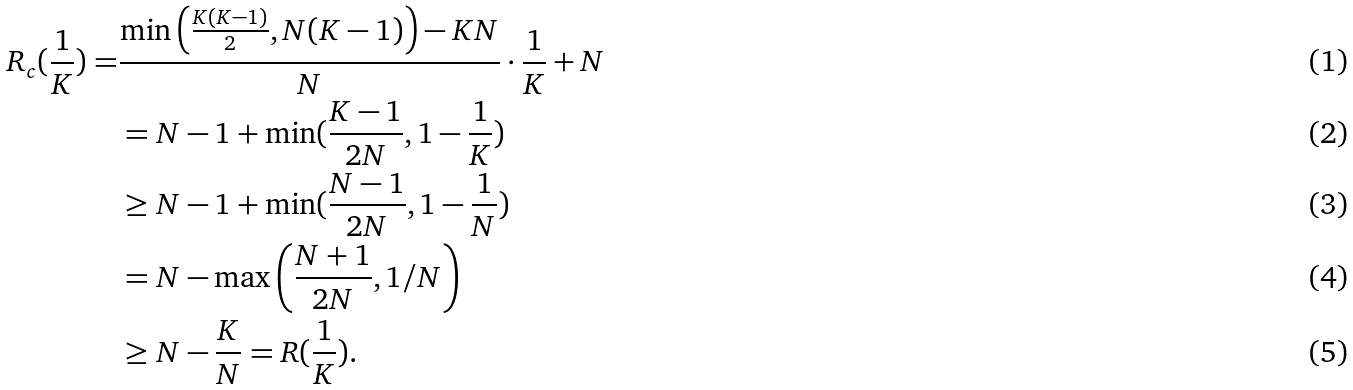<formula> <loc_0><loc_0><loc_500><loc_500>R _ { c } ( \frac { 1 } { K } ) = & \frac { \min \left ( \frac { K ( K - 1 ) } { 2 } , N ( K - 1 ) \right ) - K N } { N } \cdot \frac { 1 } { K } + N \\ & = N - 1 + \min ( \frac { K - 1 } { 2 N } , 1 - \frac { 1 } { K } ) \\ & \geq N - 1 + \min ( \frac { N - 1 } { 2 N } , 1 - \frac { 1 } { N } ) \\ & = N - \max \left ( \frac { N + 1 } { 2 N } , 1 / N \right ) \\ & \geq N - \frac { K } { N } = R ( \frac { 1 } { K } ) .</formula> 